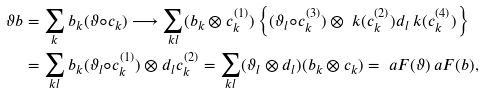<formula> <loc_0><loc_0><loc_500><loc_500>\vartheta b & = \sum _ { k } b _ { k } ( \vartheta \circ c _ { k } ) \longrightarrow \sum _ { k l } ( b _ { k } \otimes c _ { k } ^ { ( 1 ) } ) \left \{ ( \vartheta _ { l } \circ c _ { k } ^ { ( 3 ) } ) \otimes \ k ( c _ { k } ^ { ( 2 ) } ) d _ { l } \ k ( c _ { k } ^ { ( 4 ) } ) \right \} \\ & = \sum _ { k l } b _ { k } ( \vartheta _ { l } \circ c _ { k } ^ { ( 1 ) } ) \otimes d _ { l } c _ { k } ^ { ( 2 ) } = \sum _ { k l } ( \vartheta _ { l } \otimes d _ { l } ) ( b _ { k } \otimes c _ { k } ) = \ a F ( \vartheta ) \ a F ( b ) ,</formula> 